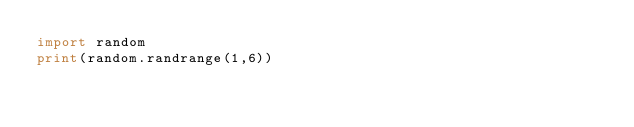Convert code to text. <code><loc_0><loc_0><loc_500><loc_500><_Python_>import random
print(random.randrange(1,6))</code> 